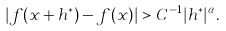Convert formula to latex. <formula><loc_0><loc_0><loc_500><loc_500>| f ( x + h ^ { * } ) - f ( x ) | > C ^ { - 1 } | h ^ { * } | ^ { \alpha } .</formula> 